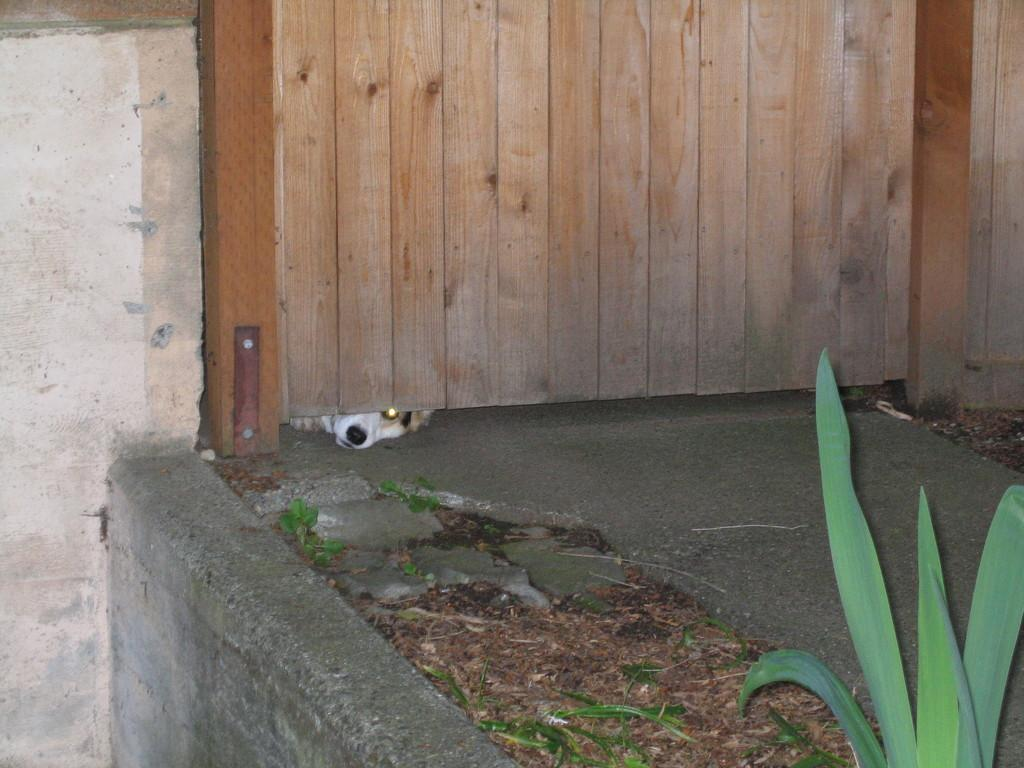What type of structure is present at the bottom of the image? There is a wooden gate in the image. What animal can be seen at the bottom of the image? There is a dog at the bottom of the image. What is on the left side of the image? There is a wall on the left side of the image. Where is the small plant located in the image? There is a small plant on the right side of the image, beside the road. How many babies are visible in the image? There are no babies present in the image. What type of bushes can be seen growing near the wall in the image? There is no mention of bushes in the provided facts, and therefore we cannot determine if any are present in the image. What season is depicted in the image? The provided facts do not mention any seasonal details, so we cannot determine the season from the image. 